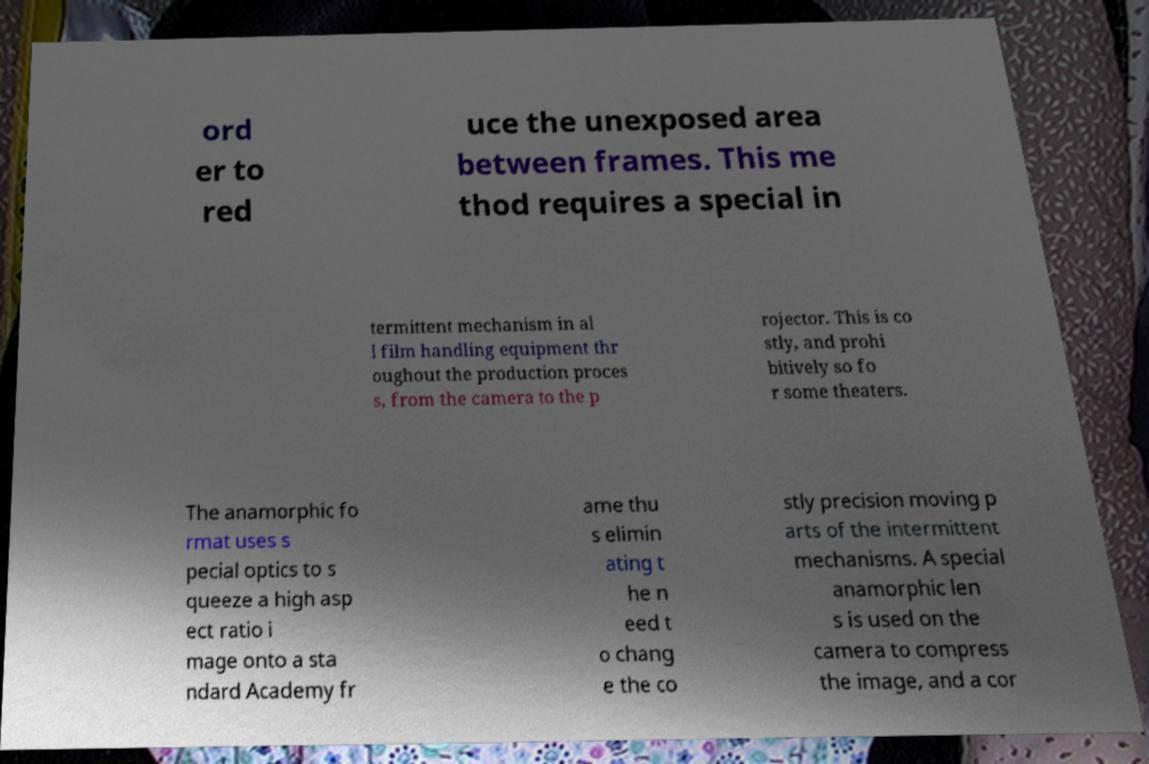Please identify and transcribe the text found in this image. ord er to red uce the unexposed area between frames. This me thod requires a special in termittent mechanism in al l film handling equipment thr oughout the production proces s, from the camera to the p rojector. This is co stly, and prohi bitively so fo r some theaters. The anamorphic fo rmat uses s pecial optics to s queeze a high asp ect ratio i mage onto a sta ndard Academy fr ame thu s elimin ating t he n eed t o chang e the co stly precision moving p arts of the intermittent mechanisms. A special anamorphic len s is used on the camera to compress the image, and a cor 